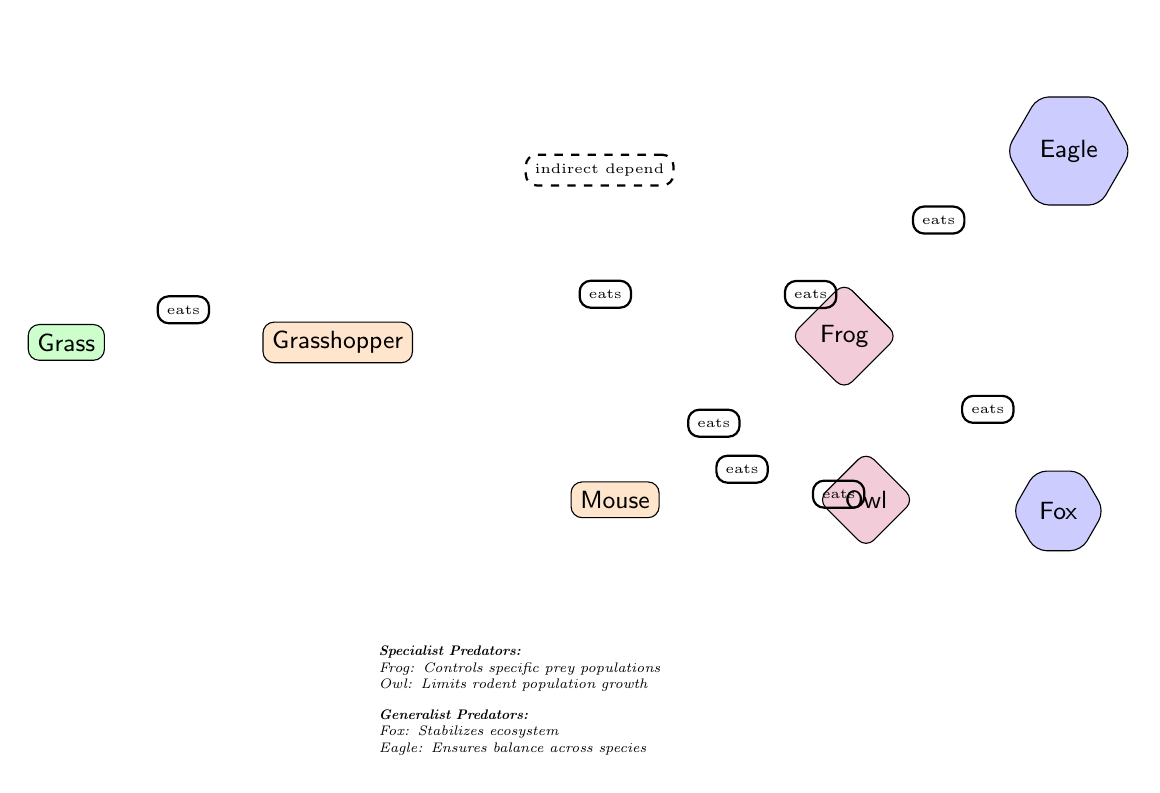What is the primary producer in the food chain? The diagram clearly indicates that the primary producer at the base of the food chain is the grass, which is represented as the first node.
Answer: Grass How many consumer nodes are there? By counting the nodes labeled as consumers (Grasshopper, Mouse), we find that there are three consumer nodes connected in the food chain.
Answer: 3 Which predator directly eats the Frog? The Eagle is illustrated as the predator that directly feeds on the Frog in the food chain diagram.
Answer: Eagle What type of predator is represented by the Owl? The Owl is represented as a specialist predator, depicted by its diamond-shaped node in the diagram.
Answer: Specialist What role does the Fox play in the ecosystem according to the diagram? The diagram describes the Fox as a generalist predator that stabilizes the ecosystem, indicating its wider ecological role beyond just hunting.
Answer: Stabilizes ecosystem Which predator has an indirect dependency on the Grass? The Fox has a dashed line indicating an indirect dependency on the Grass, signifying it relies on the ecological health which the Grass contributes to.
Answer: Fox What does the Frog control in the food chain? The diagram states that the Frog controls specific prey populations, emphasizing its role in maintaining balance within those populations.
Answer: Specific prey populations Which two predators control the mouse population? Both the Owl (specialist) and the Frog (specialist) are shown to eat the Mouse, indicating they both control its population.
Answer: Owl and Frog What type of predator is the Eagle? The Eagle is characterized as a generalist predator in the diagram, illustrated with a regular polygon shape, distinguishing it from specialist predators.
Answer: Generalist 